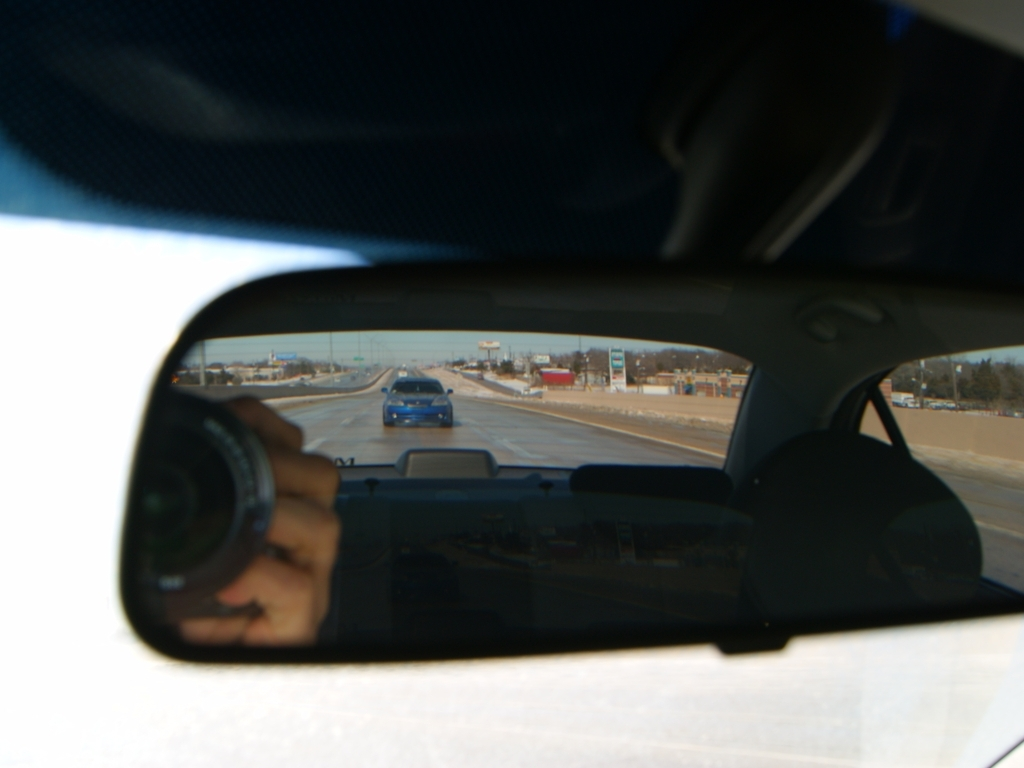Describe how the elements visible in the mirror and the windshield might symbolize modern life. The elements visible, including the camera in the mirror and cars on the road, reflect facets of modern life—constant surveillance and the ubiquitous presence of technology, juxtaposed with the ongoing journey and movement characteristic of contemporary society. This duality highlights a world where personal and public realms often intersect and where observation plays a key role in everyday interactions. Can the quality of light seen in the image be seen as symbolic in any way? The varied quality of light, ranging from the overexposed areas to well-lit aspects, can be interpreted as symbolic of clarity and obscurity in our lives. Overexposure in the windshield might symbolize the often overwhelming nature of facing the future or the unknown, while the clearer, reflective surface of the mirror suggests a sharper, although possibly distorted, understanding of the present or the past. 